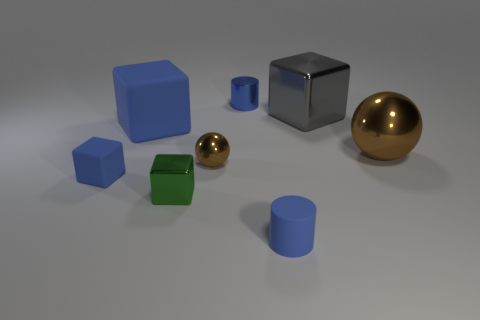Is the size of the metallic cylinder the same as the gray object?
Ensure brevity in your answer.  No. How many blue cylinders are there?
Provide a succinct answer. 2. There is another small thing that is the same shape as the green thing; what material is it?
Give a very brief answer. Rubber. Are there fewer green blocks behind the small blue matte block than red rubber spheres?
Provide a succinct answer. No. There is a small object in front of the green shiny cube; does it have the same shape as the blue shiny thing?
Ensure brevity in your answer.  Yes. Is there anything else that is the same color as the big matte block?
Ensure brevity in your answer.  Yes. There is a green block that is made of the same material as the big gray thing; what size is it?
Give a very brief answer. Small. The cylinder to the left of the tiny cylinder to the right of the blue cylinder that is behind the big metal ball is made of what material?
Give a very brief answer. Metal. Are there fewer green metal blocks than small yellow spheres?
Provide a short and direct response. No. Do the big blue thing and the large brown object have the same material?
Give a very brief answer. No. 